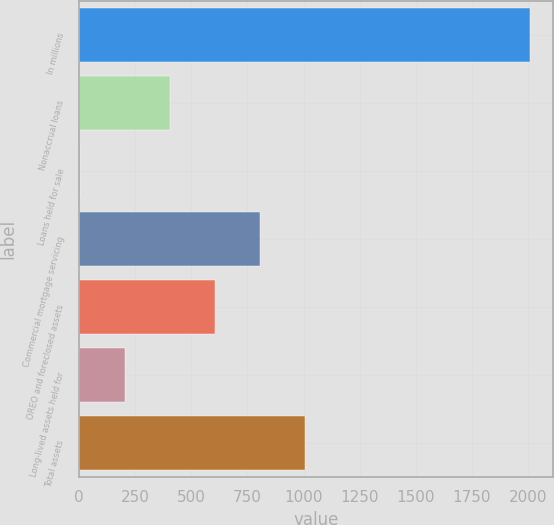Convert chart to OTSL. <chart><loc_0><loc_0><loc_500><loc_500><bar_chart><fcel>In millions<fcel>Nonaccrual loans<fcel>Loans held for sale<fcel>Commercial mortgage servicing<fcel>OREO and foreclosed assets<fcel>Long-lived assets held for<fcel>Total assets<nl><fcel>2011<fcel>403.8<fcel>2<fcel>805.6<fcel>604.7<fcel>202.9<fcel>1006.5<nl></chart> 